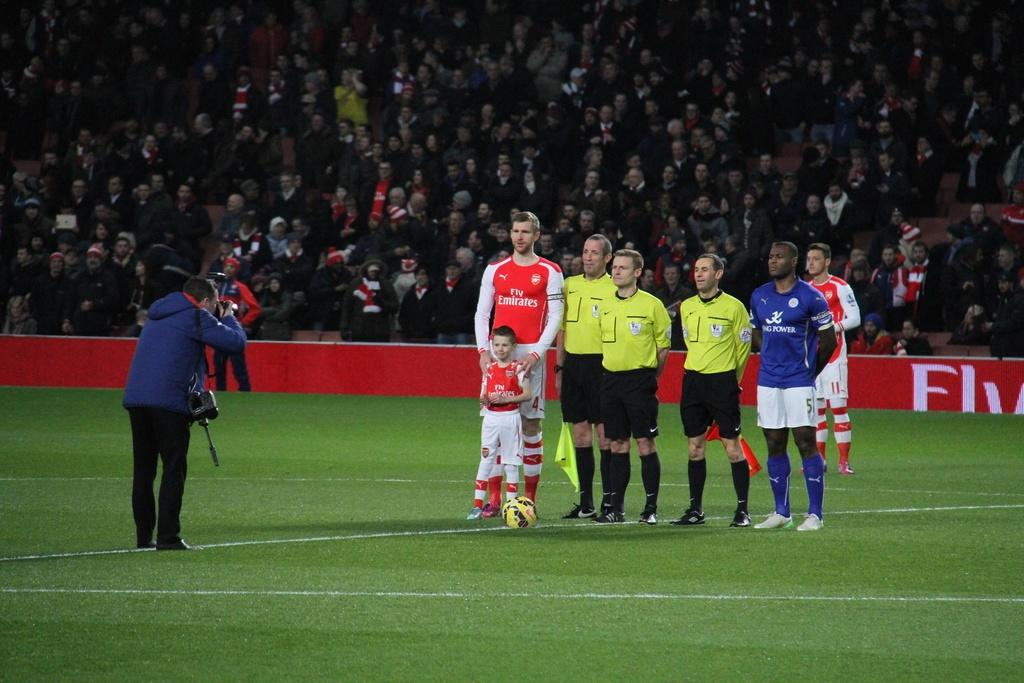<image>
Relay a brief, clear account of the picture shown. A photographer is taking the photo of several men one of which has Fly Emirates on his shirt. 